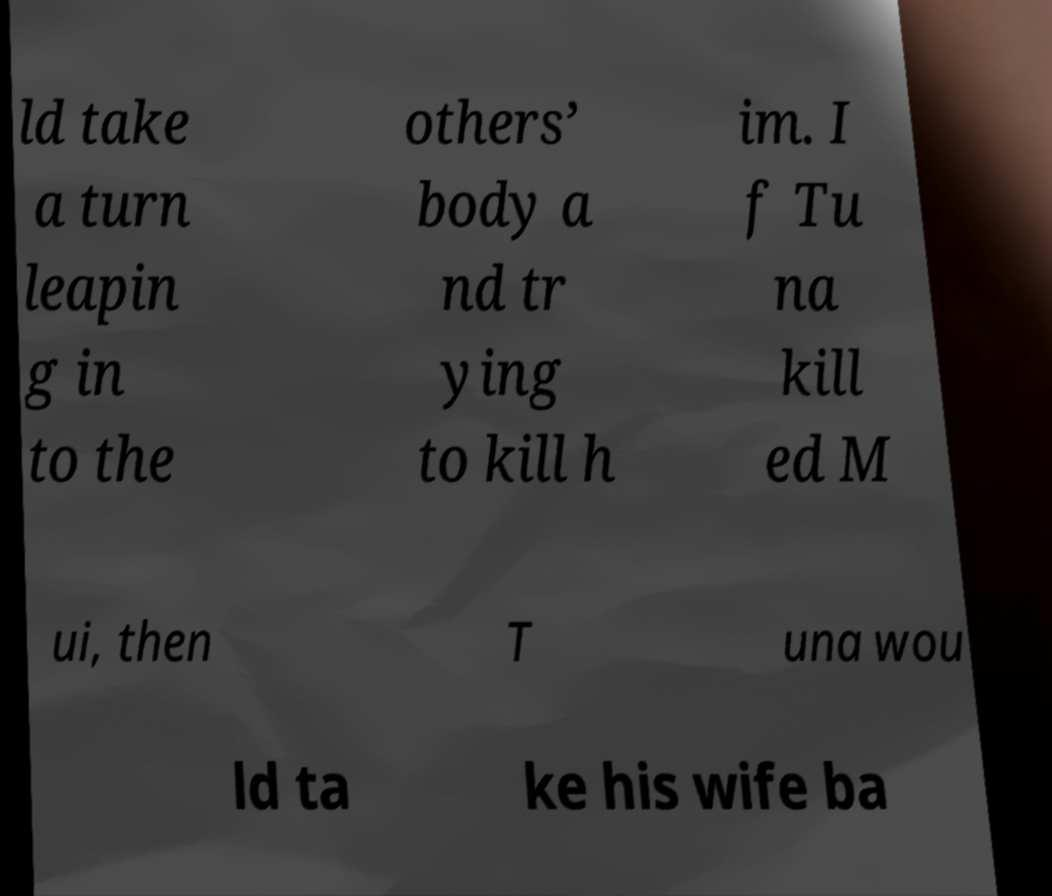Could you assist in decoding the text presented in this image and type it out clearly? ld take a turn leapin g in to the others’ body a nd tr ying to kill h im. I f Tu na kill ed M ui, then T una wou ld ta ke his wife ba 